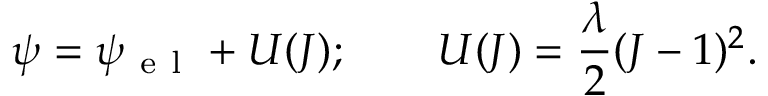Convert formula to latex. <formula><loc_0><loc_0><loc_500><loc_500>\psi = \psi _ { e l } + U ( J ) ; \quad U ( J ) = \frac { \lambda } { 2 } ( J - 1 ) ^ { 2 } .</formula> 